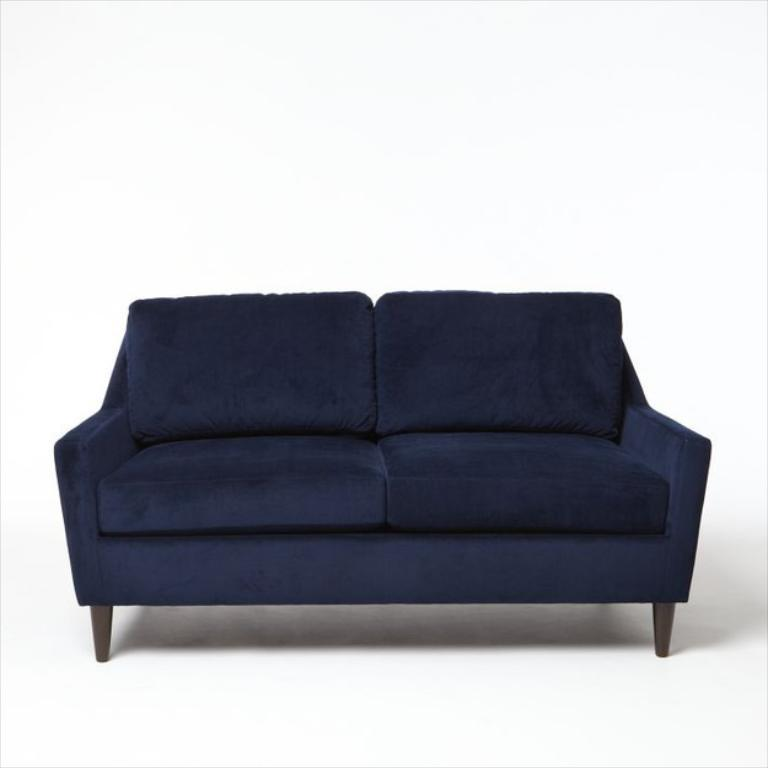What type of furniture is present in the image? There is a blue color sofa in the image. How many pigs are sitting on the blue color sofa in the image? There are no pigs present in the image; it only features a blue color sofa. What type of pain is being experienced by the person sitting on the blue color sofa in the image? There is no person or indication of pain in the image; it only features a blue color sofa. 